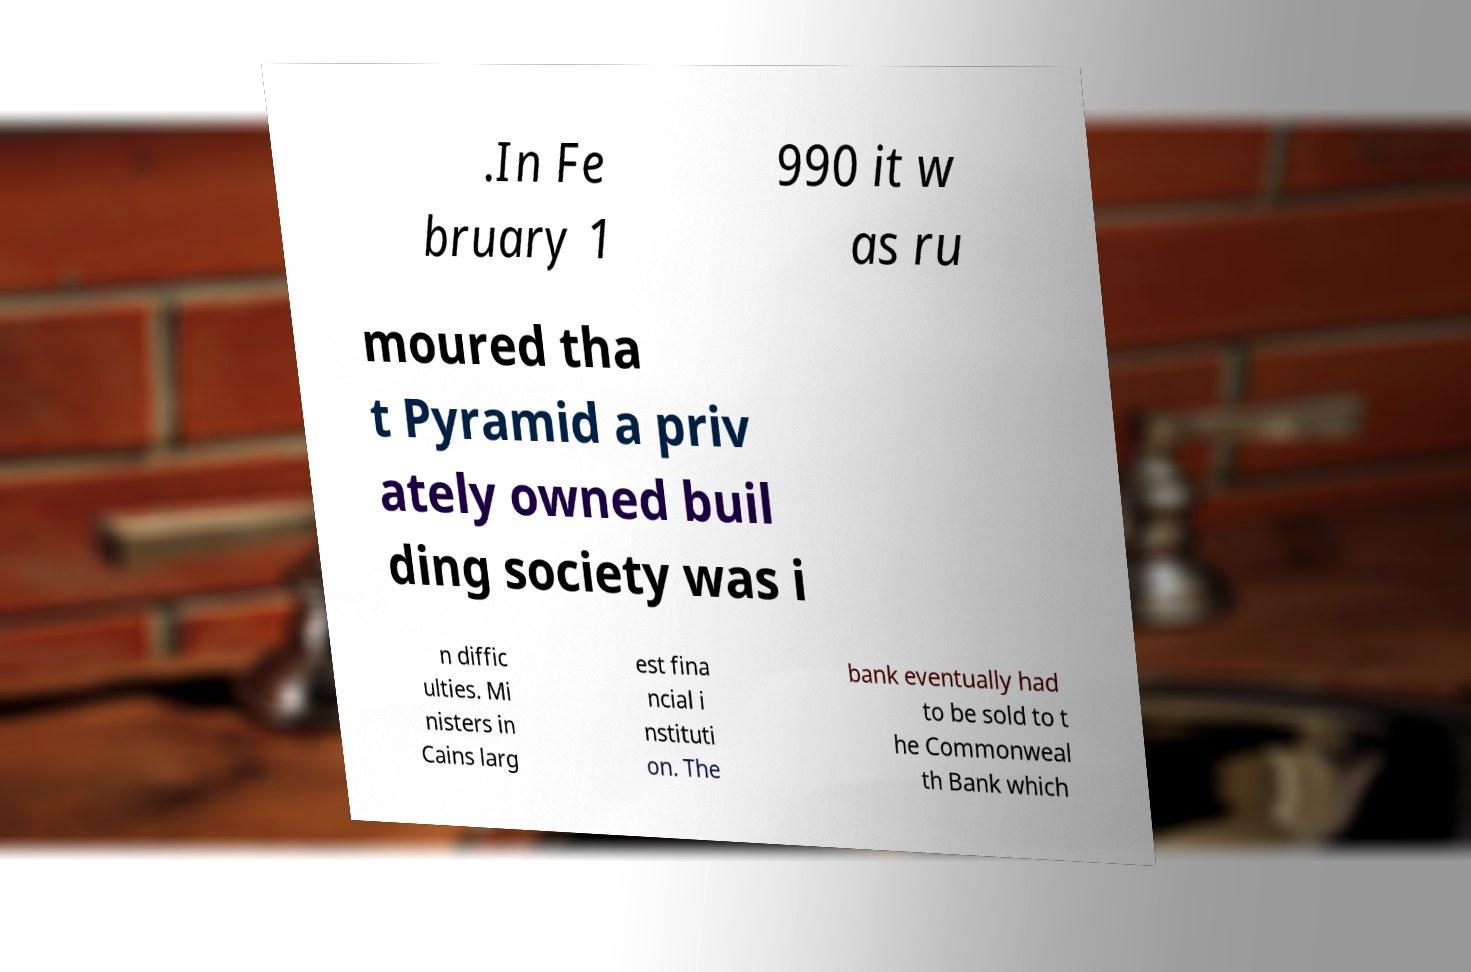Please read and relay the text visible in this image. What does it say? .In Fe bruary 1 990 it w as ru moured tha t Pyramid a priv ately owned buil ding society was i n diffic ulties. Mi nisters in Cains larg est fina ncial i nstituti on. The bank eventually had to be sold to t he Commonweal th Bank which 